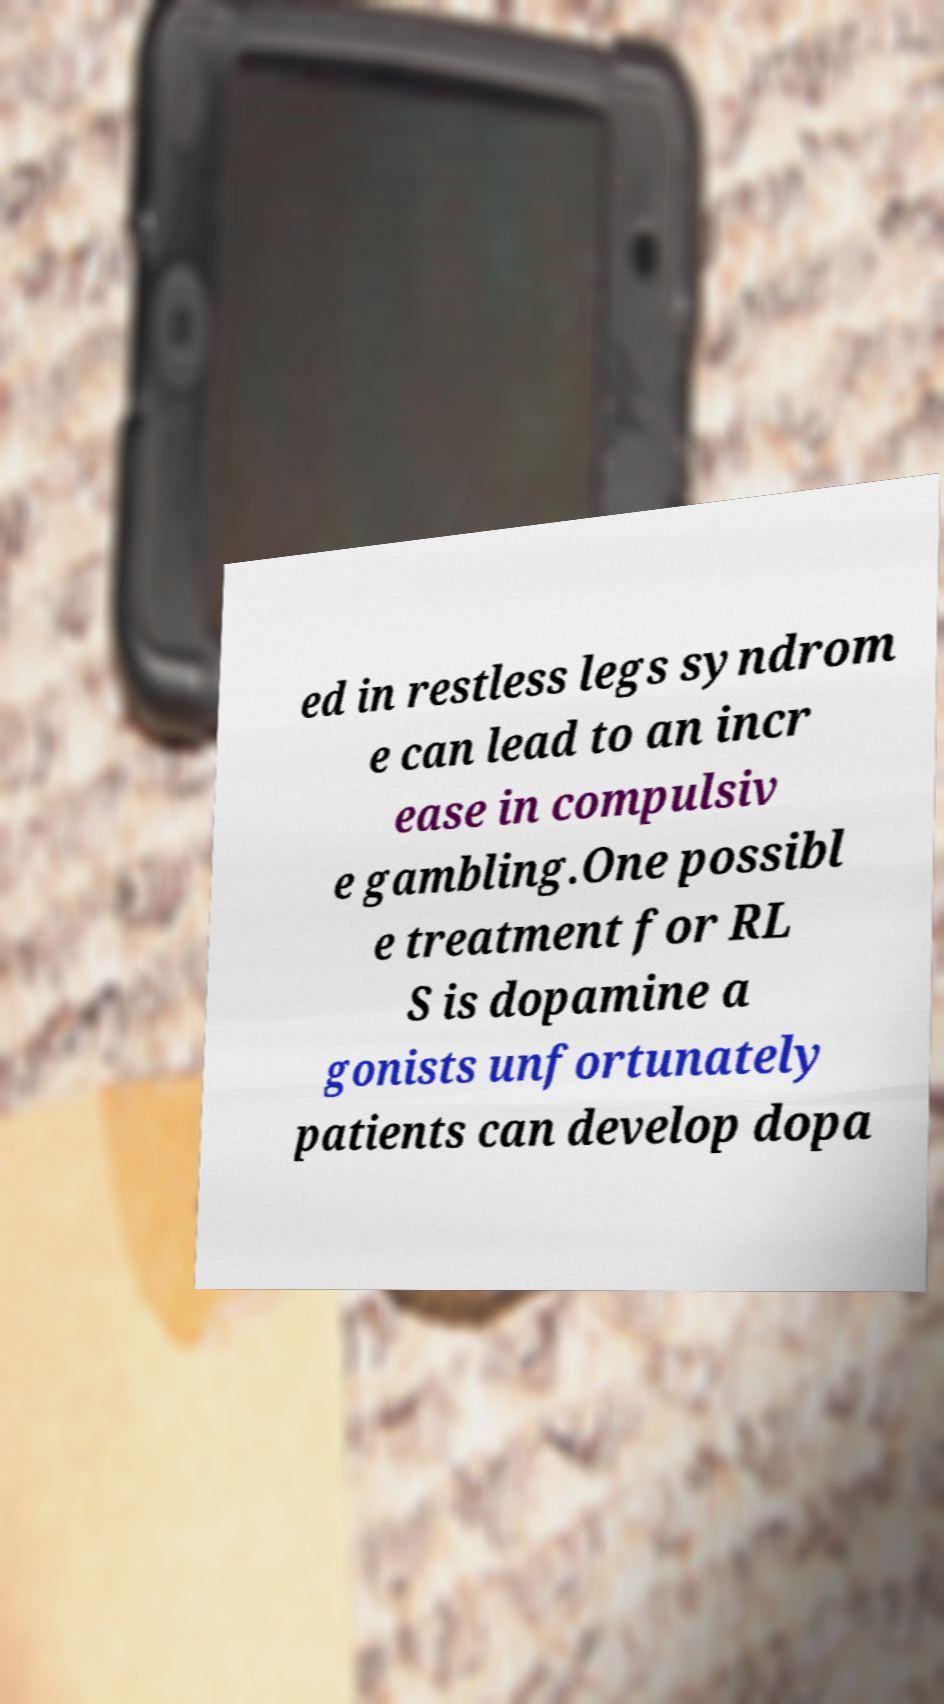For documentation purposes, I need the text within this image transcribed. Could you provide that? ed in restless legs syndrom e can lead to an incr ease in compulsiv e gambling.One possibl e treatment for RL S is dopamine a gonists unfortunately patients can develop dopa 